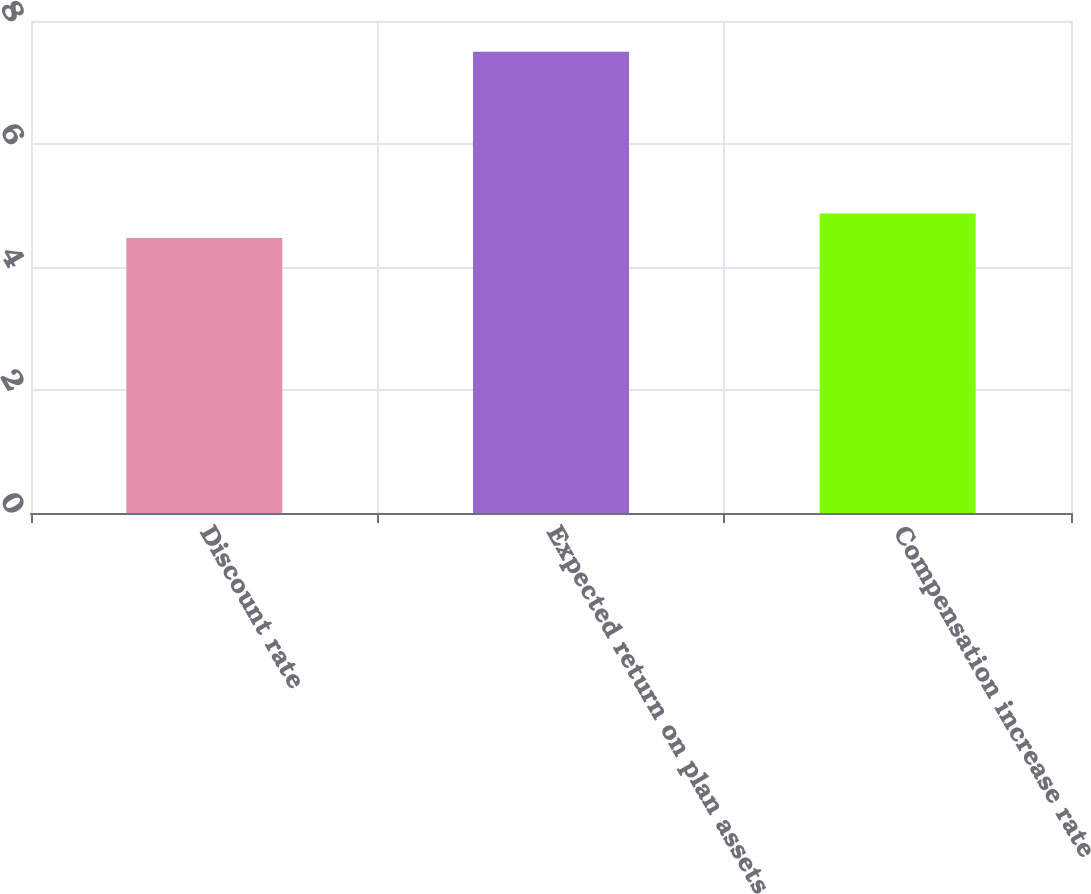<chart> <loc_0><loc_0><loc_500><loc_500><bar_chart><fcel>Discount rate<fcel>Expected return on plan assets<fcel>Compensation increase rate<nl><fcel>4.47<fcel>7.5<fcel>4.87<nl></chart> 